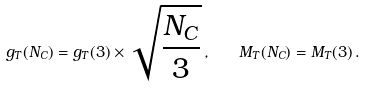<formula> <loc_0><loc_0><loc_500><loc_500>g _ { T } ( N _ { C } ) = g _ { T } ( 3 ) \times \sqrt { \frac { N _ { C } } { 3 } } \, , \quad M _ { T } ( N _ { C } ) = M _ { T } ( 3 ) \, .</formula> 